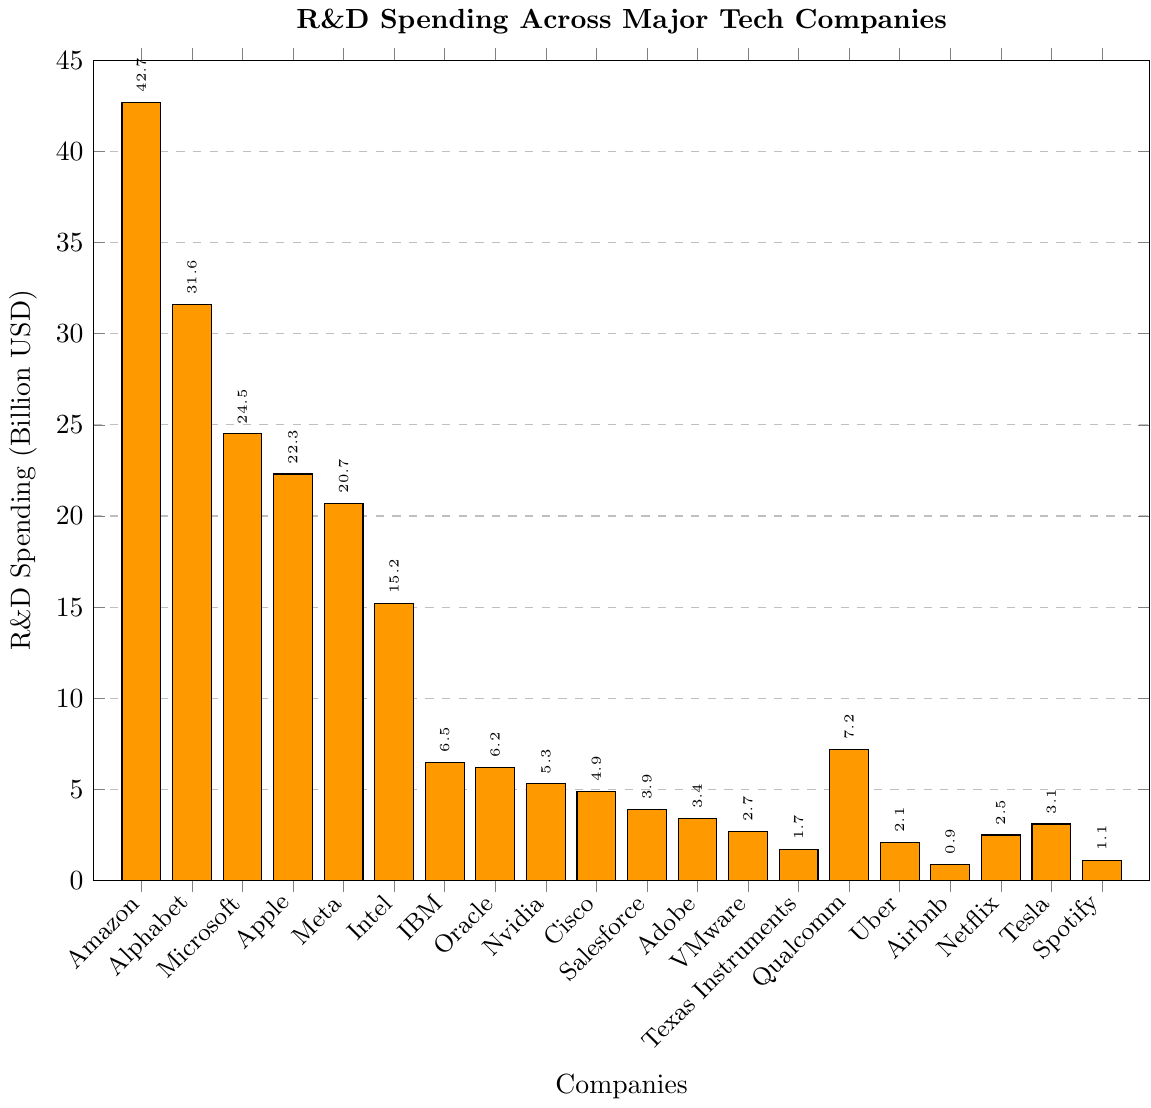Which company has the highest R&D spending? By looking at the heights of the bars, Amazon has the tallest bar, indicating it has the highest R&D spending.
Answer: Amazon Which two companies have the closest R&D spending values? By comparing the heights of all bars, Apple and Meta have near-equal heights, indicating their R&D spending values are very close to each other ($22.3B for Apple and $20.7B for Meta).
Answer: Apple and Meta What is the total R&D spending of Meta, Intel, and IBM combined? Summing up the R&D spending of Meta ($20.7B), Intel ($15.2B), and IBM ($6.5B) gives $20.7 + $15.2 + $6.5 = $42.4B.
Answer: $42.4B How much more is Amazon's R&D spending compared to Alphabet’s? Subtracting Alphabet's R&D spending ($31.6B) from Amazon's ($42.7B) gives $42.7 - $31.6 = $11.1B.
Answer: $11.1B Which company has the lowest R&D spending? Airbnb has the shortest bar, indicating the lowest R&D spending at $0.9B.
Answer: Airbnb Is Apple's R&D spending higher or lower than Microsoft's? Comparing the heights of the bars, Apple's bar is shorter than Microsoft's, indicating Apple's R&D spending ($22.3B) is lower than Microsoft's ($24.5B).
Answer: Lower What is the average R&D spending of the companies? Adding up all the R&D spending values and dividing by the number of companies (20) gives the average: $(42.7 + 31.6 + 24.5 + 22.3 + 20.7 + 15.2 + 6.5 + 6.2 + 5.3 + 4.9 + 3.9 + 3.4 + 2.7 + 1.7 + 7.2 + 2.1 + 0.9 + 2.5 + 3.1 + 1.1)/20 = 10.68B
Answer: $10.68B Which companies have an R&D spending between $5B and $10B? Oracle ($6.2B), Nvidia ($5.3B), IBM ($6.5B), Qualcomm ($7.2B), and Cisco ($4.9B) are within this range.
Answer: Oracle, Nvidia, IBM, Qualcomm How many companies have R&D spending greater than $20B? By counting the bars with heights over $20B, there are five companies: Amazon, Alphabet, Microsoft, Apple, and Meta.
Answer: 5 What is the difference in R&D spending between the highest and the lowest companies? Subtracting Airbnb's spending ($0.9B) from Amazon's highest spending ($42.7B) gives $42.7 - $0.9 = $41.8B.
Answer: $41.8B 